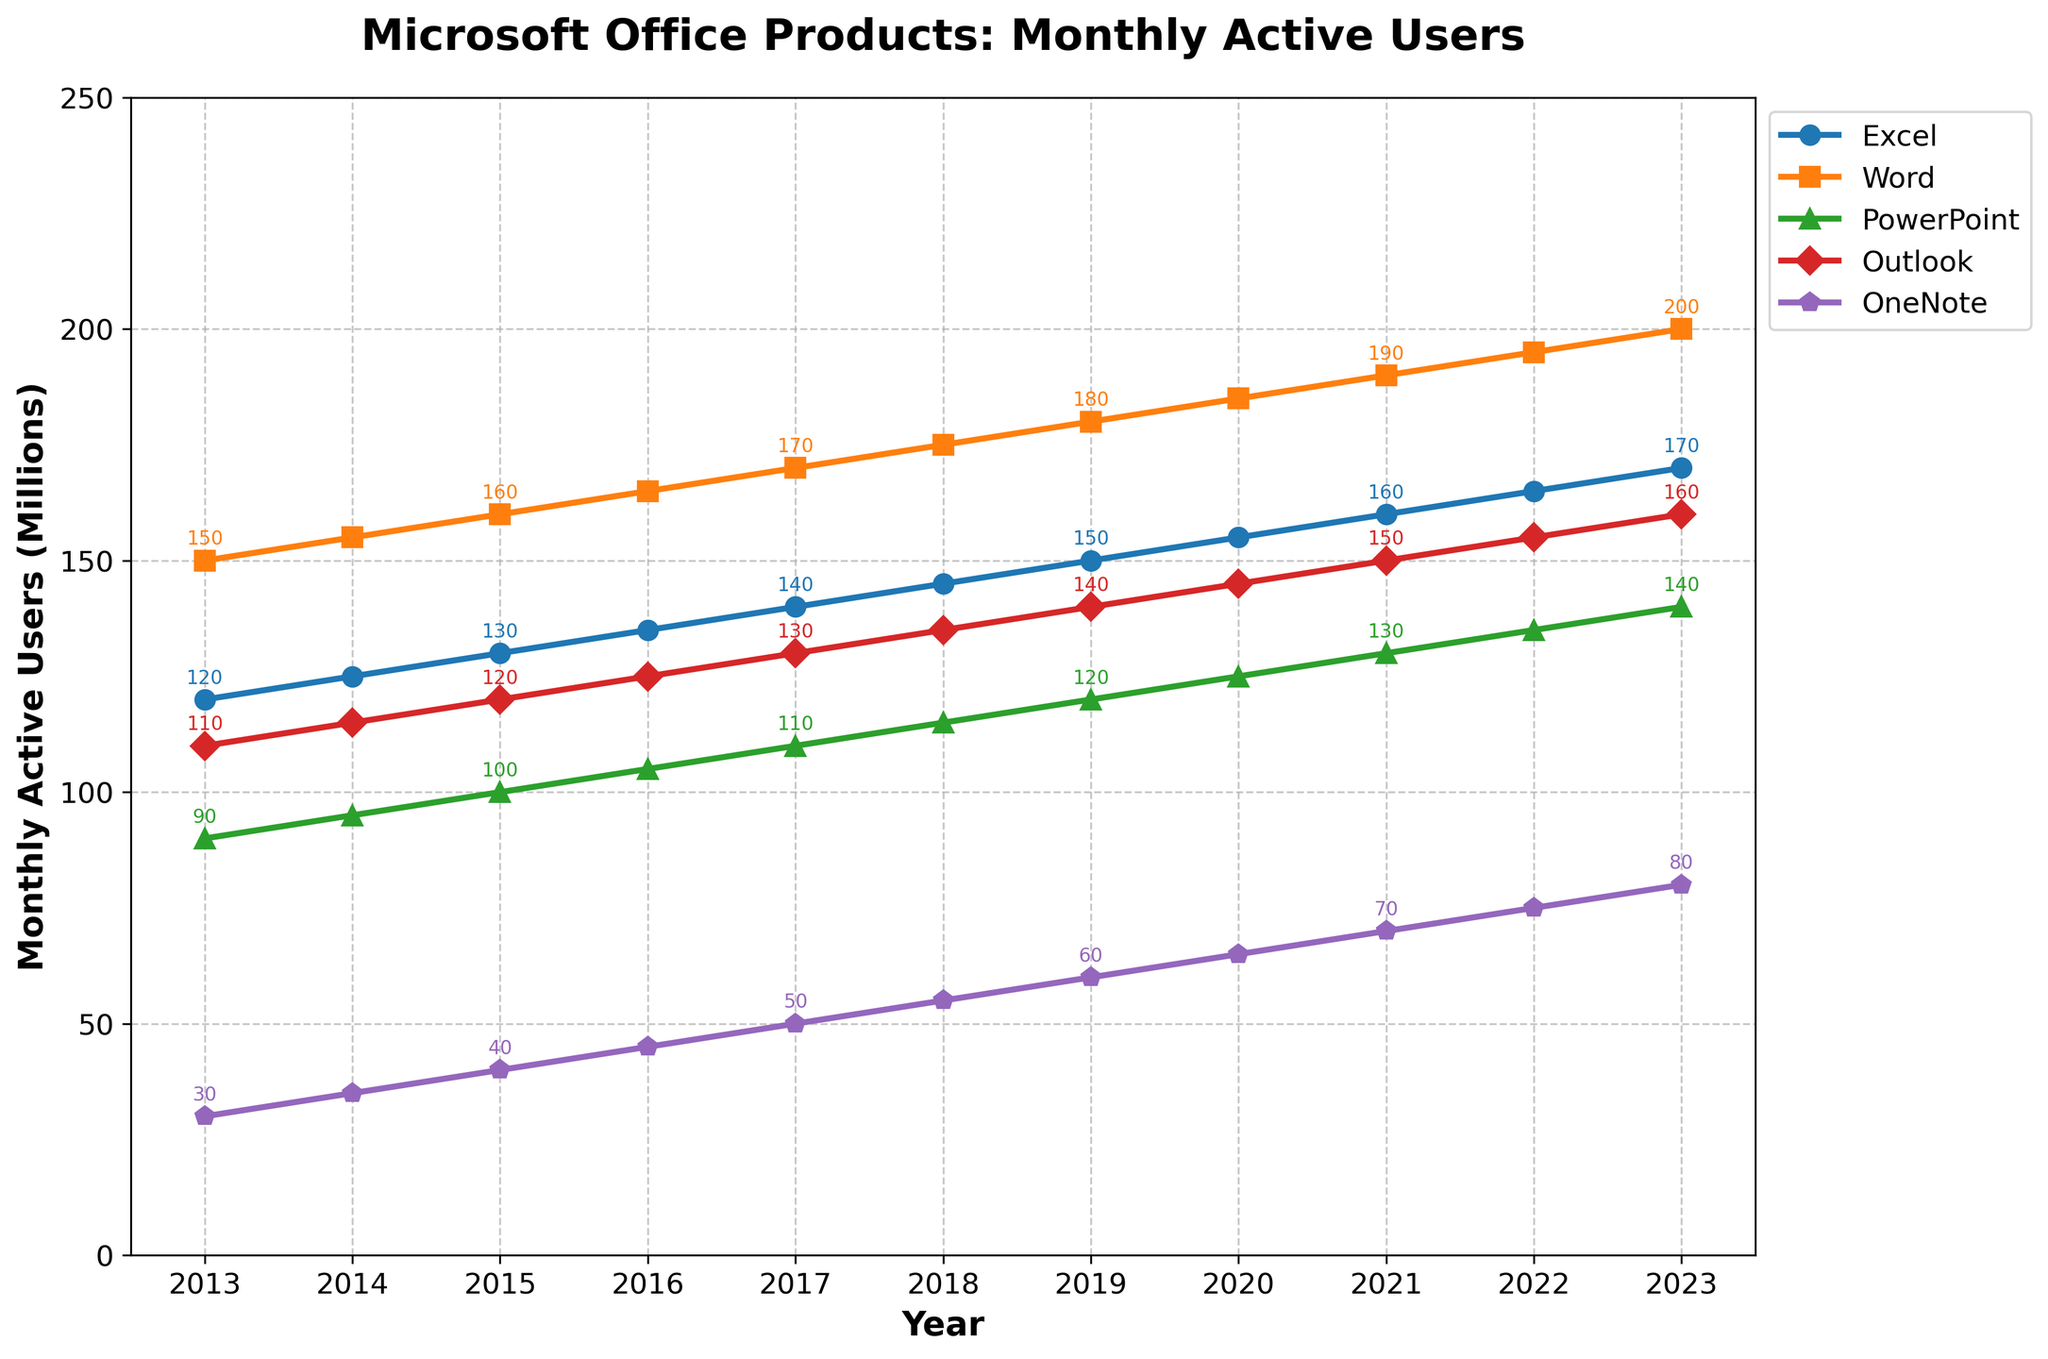How many more monthly active users did Excel have in 2023 compared to 2013? Excel had 170 million users in 2023 and 120 million in 2013. The difference is 170 - 120 = 50.
Answer: 50 million Which product had the largest increase in monthly active users from 2013 to 2023? Word had 200 million users in 2023 and 150 million in 2013. The increase is 200 - 150 = 50. Other products had smaller increases.
Answer: Word In which year did OneNote reach 60 million monthly active users? Following the OneNote line, it reached 60 million in 2019.
Answer: 2019 Between Outlook and PowerPoint, which product saw a higher growth rate from 2013 to 2023? Outlook grew from 110 million to 160 million, an increase of 50 million. PowerPoint grew from 90 million to 140 million, an increase of 50 million. Both had the same growth rate.
Answer: Equal What is the average number of monthly active users for Word from 2013 to 2023? (150+155+160+165+170+175+180+185+190+195+200)/11 = 175 million.
Answer: 175 million Which product consistently had the highest number of monthly active users between 2013 and 2023? All data points in the Word line are above the other lines.
Answer: Word What is the total number of monthly active users for all products combined in 2020? Summing the 2020 values: 155 + 185 + 125 + 145 + 65 = 675 million.
Answer: 675 million How does the trend of Excel usage from 2013 to 2023 compare with PowerPoint usage in terms of growth direction and rate? Both Excel and PowerPoint show an upward trend. Excel grows from 120 million to 170 million and PowerPoint from 90 million to 140 million. Excel's growth rate is 50 million, and PowerPoint's is also 50 million.
Answer: Similar growth direction and rate What is the difference in the number of monthly active users between OneNote and PowerPoint in 2013? OneNote had 30 million, and PowerPoint had 90 million. The difference is 90 - 30 = 60.
Answer: 60 million Which product showed a steadier growth trend over the years, Excel or Outlook? Both lines rise steadily, but Excel's increments appear more uniform compared to Outlook's.
Answer: Excel 